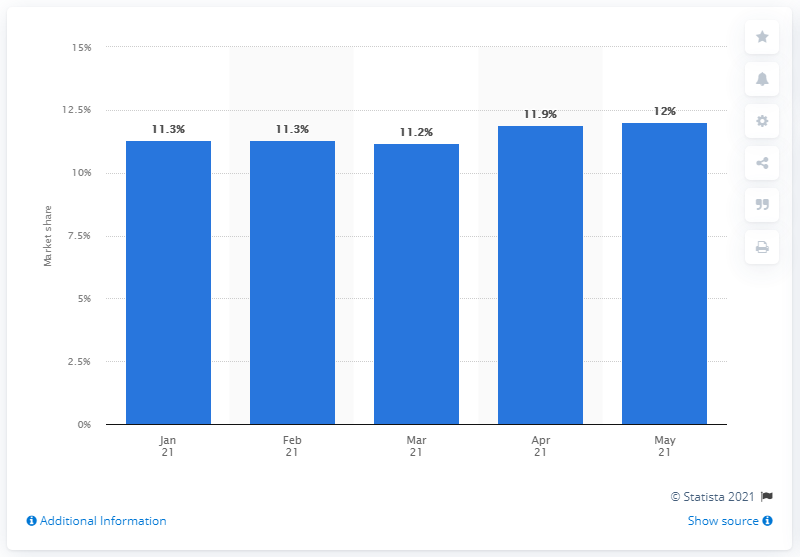Identify some key points in this picture. In May 2021, the Volkswagen brand accounted for 12% of all new-car registrations in the European Union. 